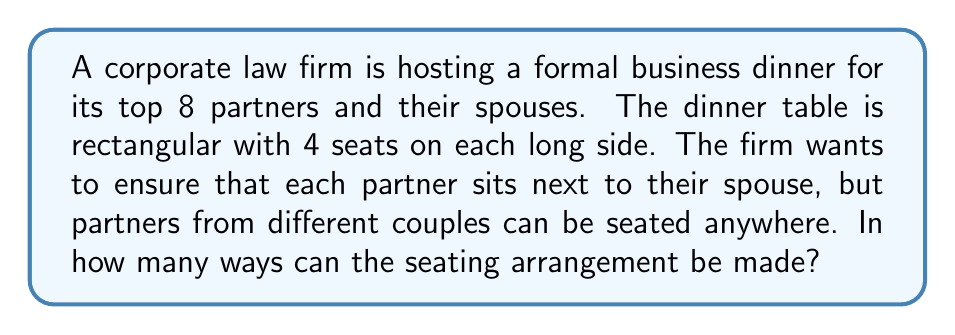Give your solution to this math problem. Let's approach this step-by-step:

1) First, we need to consider each couple as a unit. We have 8 couples in total.

2) These 8 couples need to be arranged around the table. This is equivalent to arranging 8 objects in a line, which can be done in $8!$ ways.

3) However, the table is rectangular with 4 seats on each long side. This means that rotating the entire arrangement by 180 degrees produces the same seating arrangement. To account for this, we need to divide our total by 2.

4) So far, we have: $\frac{8!}{2}$ arrangements.

5) Now, for each of these arrangements, we need to consider that each couple can be seated in 2 ways (either partner can be on the inside or outside of the table).

6) With 8 couples, this gives us $2^8$ additional arrangements for each initial arrangement.

7) Combining steps 4 and 6, our total number of arrangements is:

   $$\frac{8!}{2} \cdot 2^8$$

8) Let's calculate this:
   $$\frac{40,320}{2} \cdot 256 = 20,160 \cdot 256 = 5,160,960$$

Therefore, there are 5,160,960 possible seating arrangements.
Answer: 5,160,960 